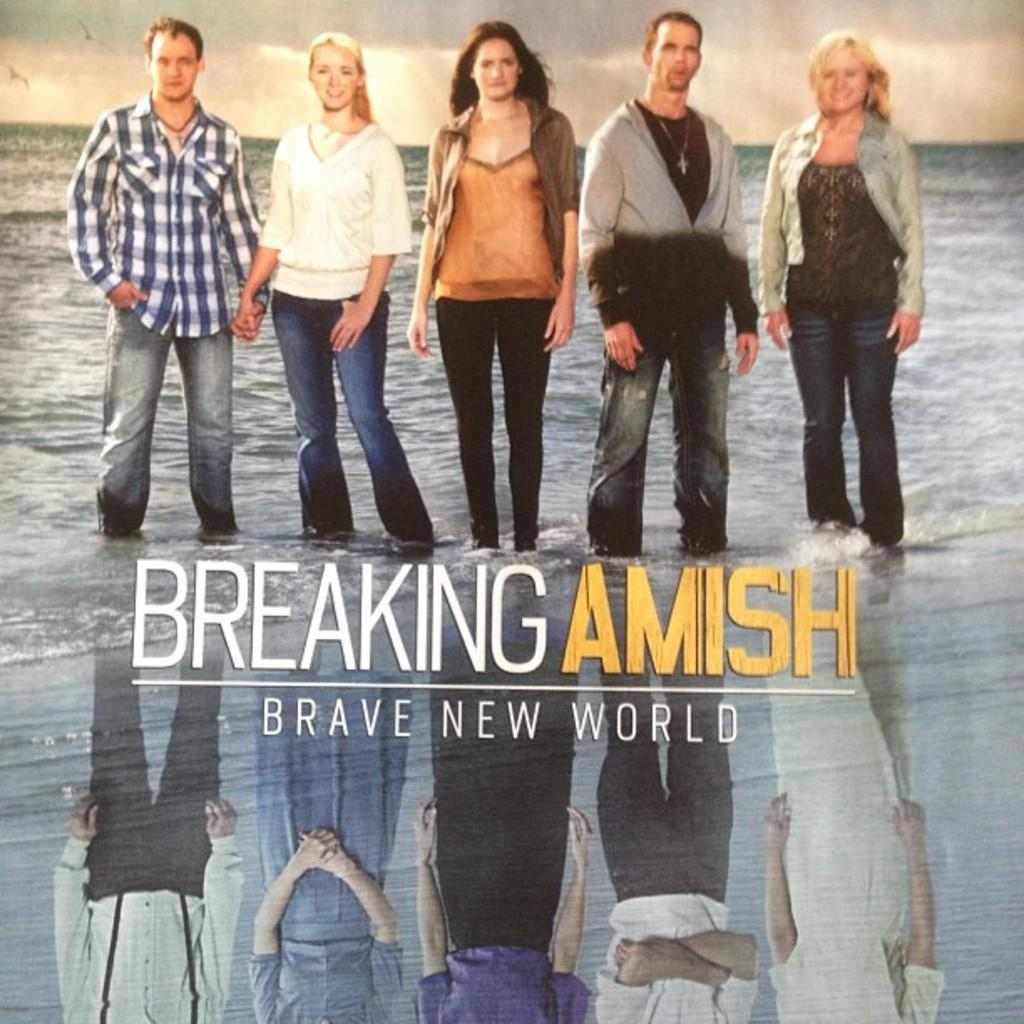What types of people are in the image? There are men and women in the image. What are the men and women doing in the image? The men and women are standing. What are the men and women wearing in the image? The men and women are wearing clothes. What is visible in the background of the image? The sky is visible in the image. How many oranges are being held by the men and women in the image? There are no oranges present in the image. What type of field can be seen in the background of the image? There is no field visible in the image; only the sky is present in the background. 